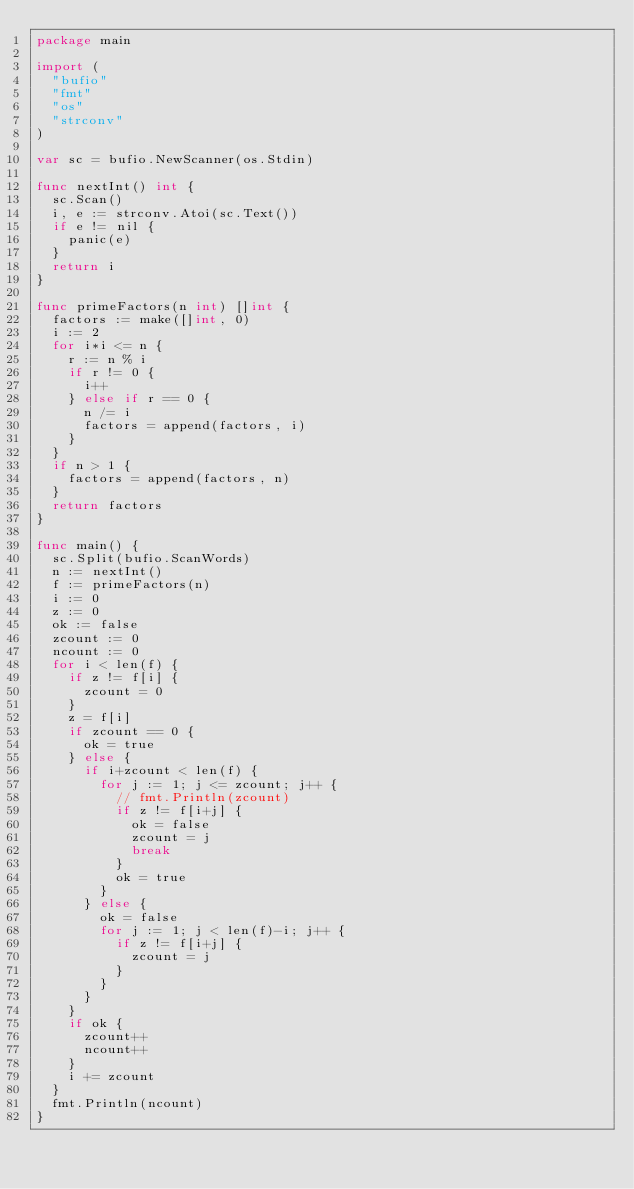<code> <loc_0><loc_0><loc_500><loc_500><_Go_>package main

import (
	"bufio"
	"fmt"
	"os"
	"strconv"
)

var sc = bufio.NewScanner(os.Stdin)

func nextInt() int {
	sc.Scan()
	i, e := strconv.Atoi(sc.Text())
	if e != nil {
		panic(e)
	}
	return i
}

func primeFactors(n int) []int {
	factors := make([]int, 0)
	i := 2
	for i*i <= n {
		r := n % i
		if r != 0 {
			i++
		} else if r == 0 {
			n /= i
			factors = append(factors, i)
		}
	}
	if n > 1 {
		factors = append(factors, n)
	}
	return factors
}

func main() {
	sc.Split(bufio.ScanWords)
	n := nextInt()
	f := primeFactors(n)
	i := 0
	z := 0
	ok := false
	zcount := 0
	ncount := 0
	for i < len(f) {
		if z != f[i] {
			zcount = 0
		}
		z = f[i]
		if zcount == 0 {
			ok = true
		} else {
			if i+zcount < len(f) {
				for j := 1; j <= zcount; j++ {
					// fmt.Println(zcount)
					if z != f[i+j] {
						ok = false
						zcount = j
						break
					}
					ok = true
				}
			} else {
				ok = false
				for j := 1; j < len(f)-i; j++ {
					if z != f[i+j] {
						zcount = j
					}
				}
			}
		}
		if ok {
			zcount++
			ncount++
		}
		i += zcount
	}
	fmt.Println(ncount)
}
</code> 